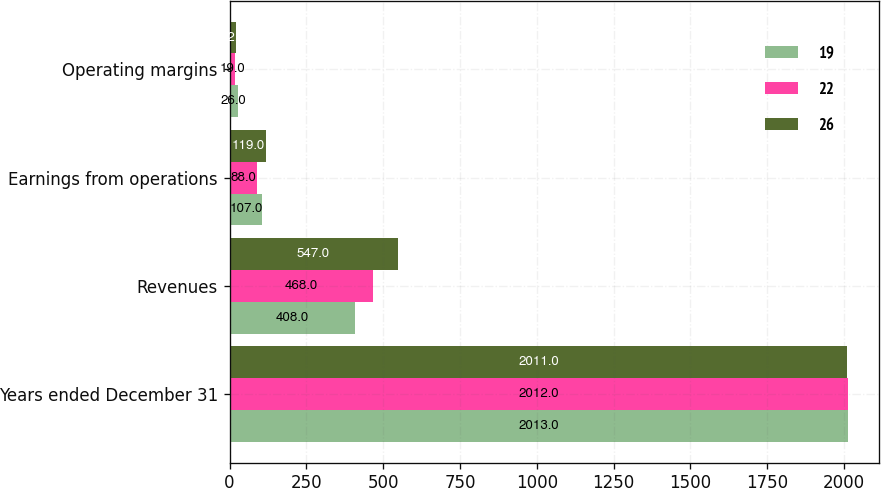Convert chart to OTSL. <chart><loc_0><loc_0><loc_500><loc_500><stacked_bar_chart><ecel><fcel>Years ended December 31<fcel>Revenues<fcel>Earnings from operations<fcel>Operating margins<nl><fcel>19<fcel>2013<fcel>408<fcel>107<fcel>26<nl><fcel>22<fcel>2012<fcel>468<fcel>88<fcel>19<nl><fcel>26<fcel>2011<fcel>547<fcel>119<fcel>22<nl></chart> 